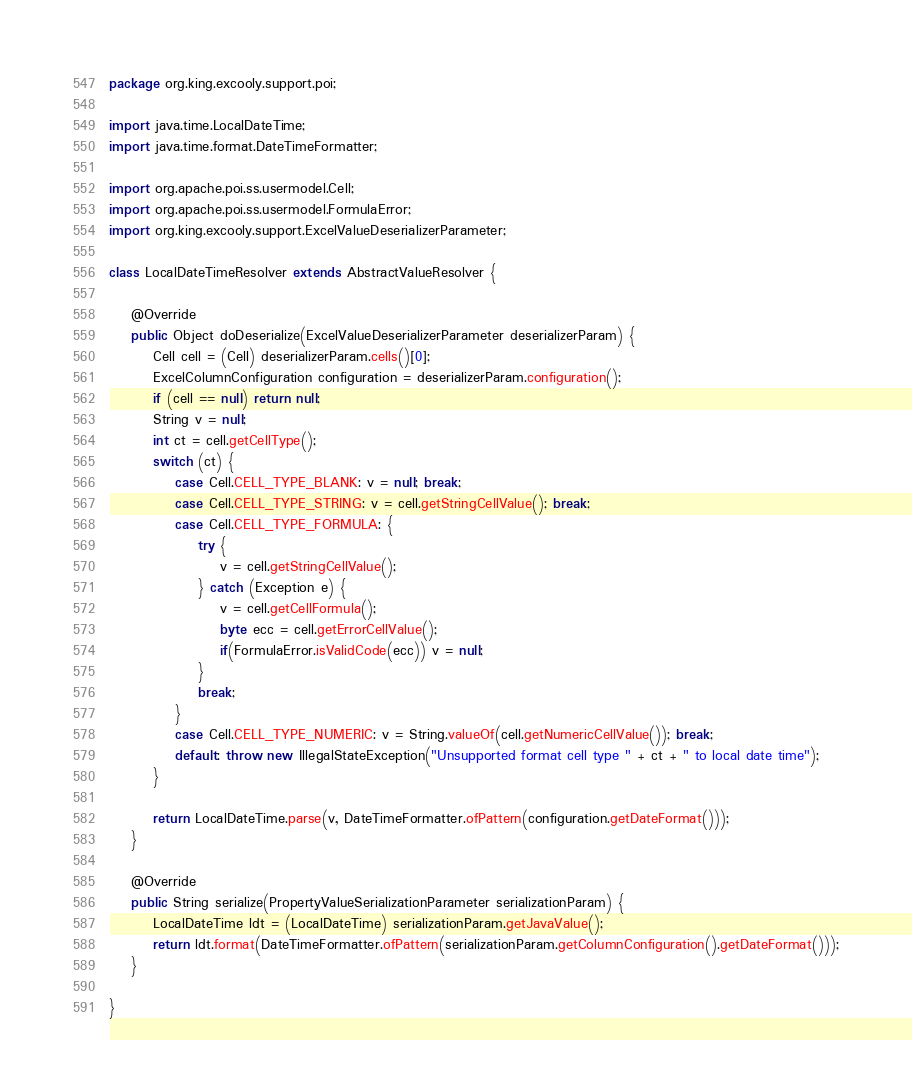Convert code to text. <code><loc_0><loc_0><loc_500><loc_500><_Java_>package org.king.excooly.support.poi;

import java.time.LocalDateTime;
import java.time.format.DateTimeFormatter;

import org.apache.poi.ss.usermodel.Cell;
import org.apache.poi.ss.usermodel.FormulaError;
import org.king.excooly.support.ExcelValueDeserializerParameter;

class LocalDateTimeResolver extends AbstractValueResolver {

	@Override
	public Object doDeserialize(ExcelValueDeserializerParameter deserializerParam) {
		Cell cell = (Cell) deserializerParam.cells()[0];
		ExcelColumnConfiguration configuration = deserializerParam.configuration();
		if (cell == null) return null;
		String v = null;
		int ct = cell.getCellType();
		switch (ct) {
			case Cell.CELL_TYPE_BLANK: v = null; break;
			case Cell.CELL_TYPE_STRING: v = cell.getStringCellValue(); break;
			case Cell.CELL_TYPE_FORMULA: {
				try {
					v = cell.getStringCellValue();
				} catch (Exception e) {
					v = cell.getCellFormula();
					byte ecc = cell.getErrorCellValue();
					if(FormulaError.isValidCode(ecc)) v = null;
				}
				break;
			}
			case Cell.CELL_TYPE_NUMERIC: v = String.valueOf(cell.getNumericCellValue()); break;
			default: throw new IllegalStateException("Unsupported format cell type " + ct + " to local date time");
		}
		
		return LocalDateTime.parse(v, DateTimeFormatter.ofPattern(configuration.getDateFormat()));
	}

	@Override
	public String serialize(PropertyValueSerializationParameter serializationParam) {
		LocalDateTime ldt = (LocalDateTime) serializationParam.getJavaValue();
		return ldt.format(DateTimeFormatter.ofPattern(serializationParam.getColumnConfiguration().getDateFormat()));
	}

}
</code> 